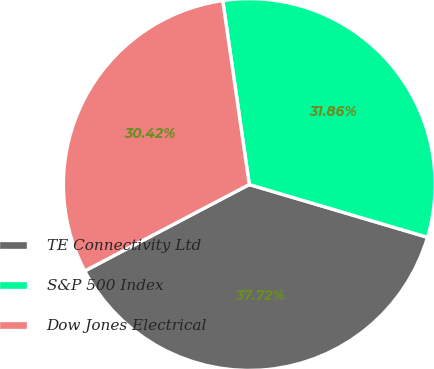Convert chart to OTSL. <chart><loc_0><loc_0><loc_500><loc_500><pie_chart><fcel>TE Connectivity Ltd<fcel>S&P 500 Index<fcel>Dow Jones Electrical<nl><fcel>37.72%<fcel>31.86%<fcel>30.42%<nl></chart> 